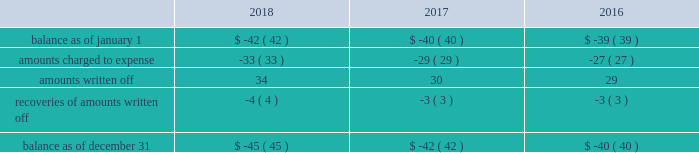Note 6 : allowance for uncollectible accounts the table provides the changes in the allowances for uncollectible accounts for the years ended december 31: .
Note 7 : regulatory assets and liabilities regulatory assets regulatory assets represent costs that are probable of recovery from customers in future rates .
The majority of the regulatory assets earn a return .
The following table provides the composition of regulatory assets as of december 31 : 2018 2017 deferred pension expense .
$ 362 $ 285 removal costs recoverable through rates .
292 269 regulatory balancing accounts .
110 113 san clemente dam project costs .
85 89 debt expense .
70 67 purchase premium recoverable through rates .
56 57 deferred tank painting costs .
42 42 make-whole premium on early extinguishment of debt .
33 27 other .
106 112 total regulatory assets .
$ 1156 $ 1061 the company 2019s deferred pension expense includes a portion of the underfunded status that is probable of recovery through rates in future periods of $ 352 million and $ 270 million as of december 31 , 2018 and 2017 , respectively .
The remaining portion is the pension expense in excess of the amount contributed to the pension plans which is deferred by certain subsidiaries and will be recovered in future service rates as contributions are made to the pension plan .
Removal costs recoverable through rates represent costs incurred for removal of property , plant and equipment or other retirement costs .
Regulatory balancing accounts accumulate differences between revenues recognized and authorized revenue requirements until they are collected from customers or are refunded .
Regulatory balancing accounts include low income programs and purchased power and water accounts .
San clemente dam project costs represent costs incurred and deferred by the company 2019s utility subsidiary in california pursuant to its efforts to investigate alternatives and remove the dam due to potential earthquake and flood safety concerns .
In june 2012 , the california public utilities commission ( 201ccpuc 201d ) issued a decision authorizing implementation of a project to reroute the carmel river and remove the san clemente dam .
The project includes the company 2019s utility subsidiary in california , the california state conservancy and the national marine fisheries services .
Under the order 2019s terms , the cpuc has authorized recovery for .
What was the decrease in the total balance as of december 31 2018 from 2017? 
Computations: ((42 * const_m1) - -45)
Answer: 3.0. 